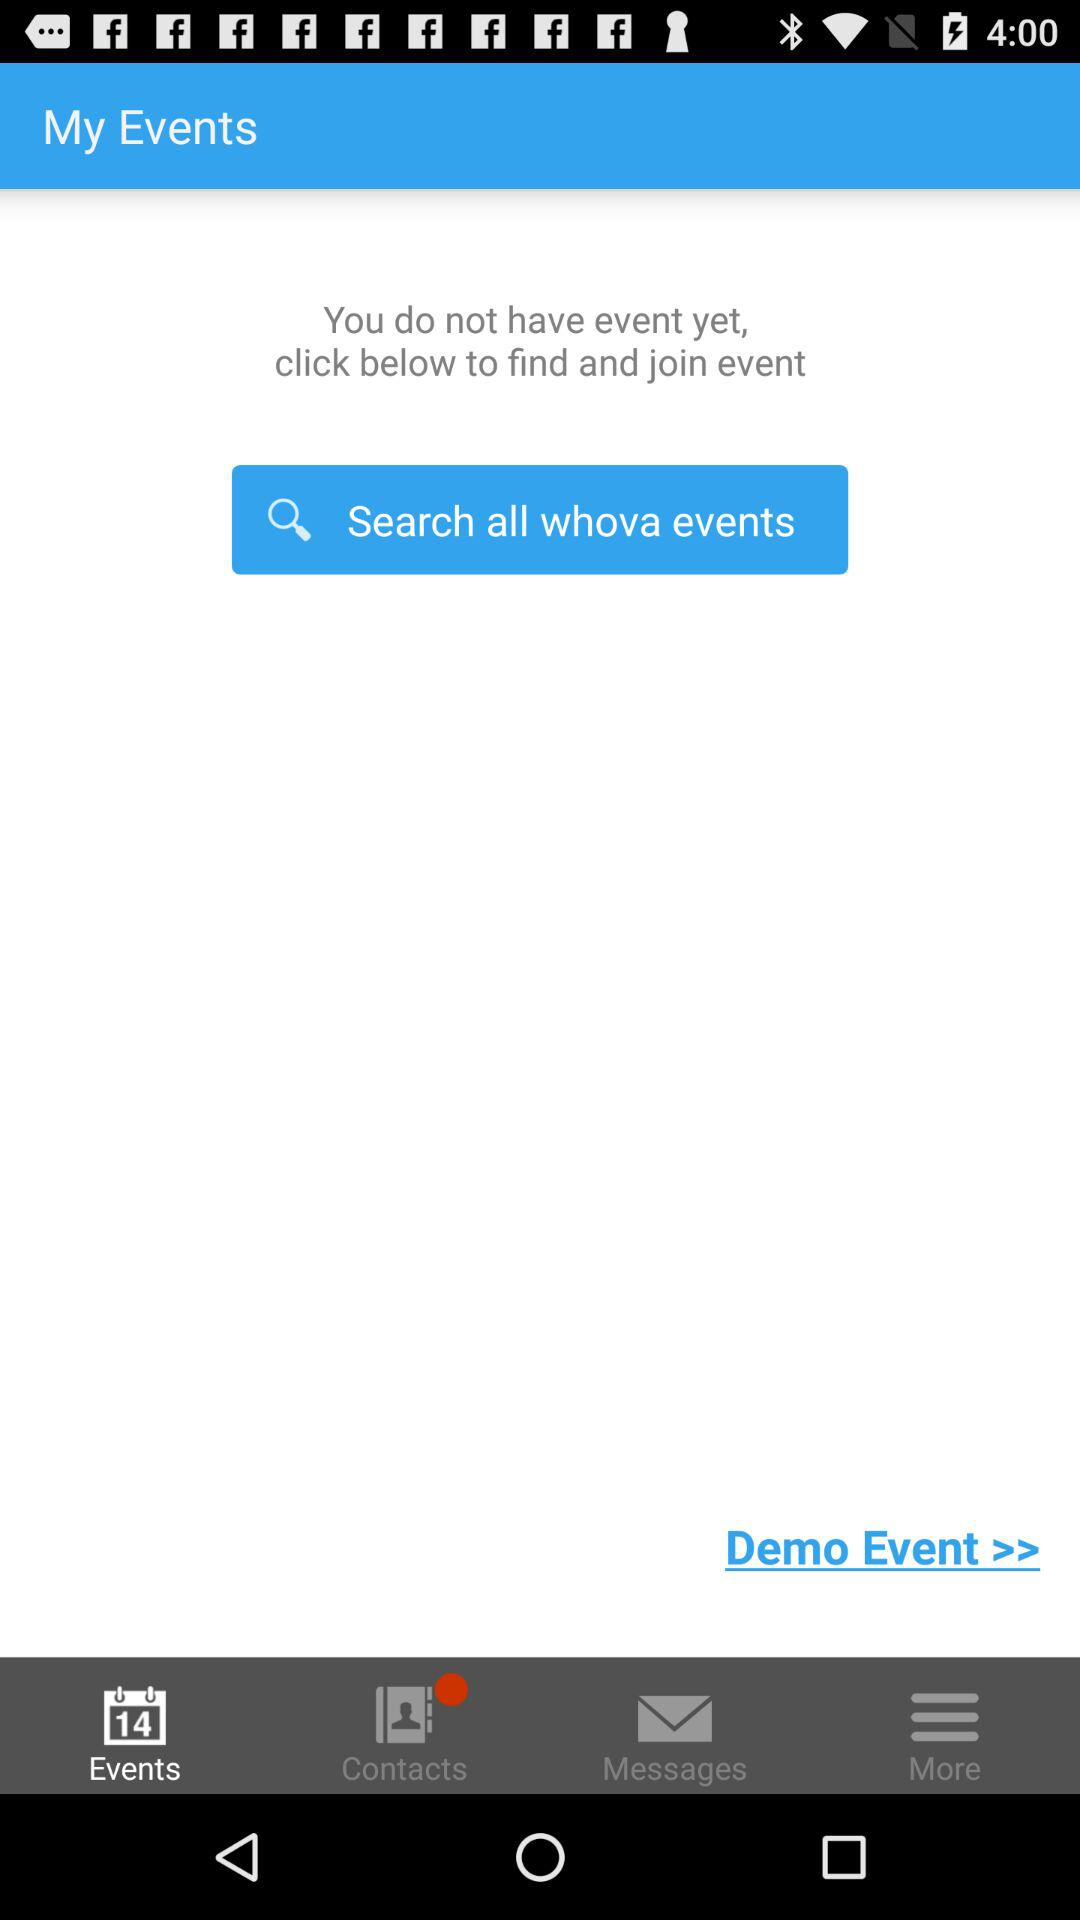How many events does the user have?
Answer the question using a single word or phrase. 0 